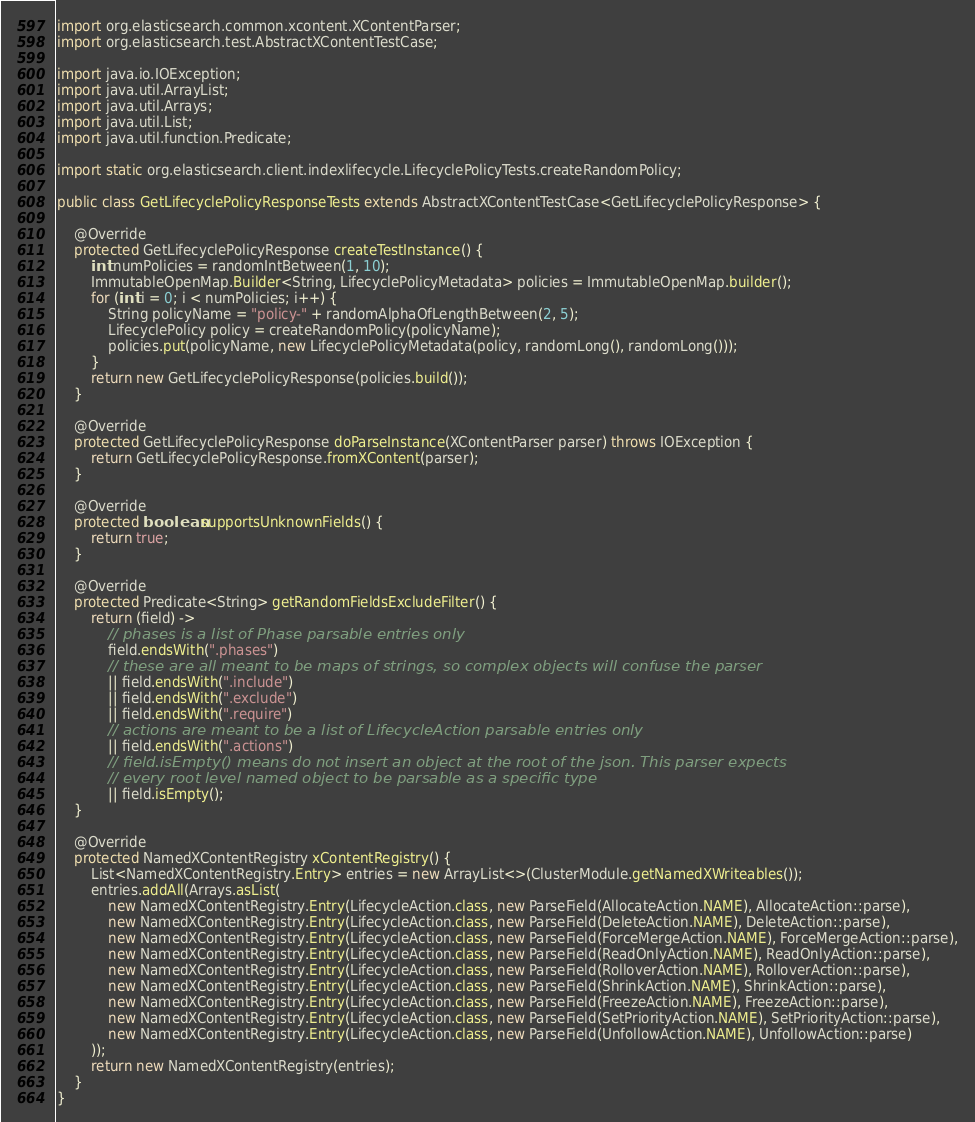<code> <loc_0><loc_0><loc_500><loc_500><_Java_>import org.elasticsearch.common.xcontent.XContentParser;
import org.elasticsearch.test.AbstractXContentTestCase;

import java.io.IOException;
import java.util.ArrayList;
import java.util.Arrays;
import java.util.List;
import java.util.function.Predicate;

import static org.elasticsearch.client.indexlifecycle.LifecyclePolicyTests.createRandomPolicy;

public class GetLifecyclePolicyResponseTests extends AbstractXContentTestCase<GetLifecyclePolicyResponse> {

    @Override
    protected GetLifecyclePolicyResponse createTestInstance() {
        int numPolicies = randomIntBetween(1, 10);
        ImmutableOpenMap.Builder<String, LifecyclePolicyMetadata> policies = ImmutableOpenMap.builder();
        for (int i = 0; i < numPolicies; i++) {
            String policyName = "policy-" + randomAlphaOfLengthBetween(2, 5);
            LifecyclePolicy policy = createRandomPolicy(policyName);
            policies.put(policyName, new LifecyclePolicyMetadata(policy, randomLong(), randomLong()));
        }
        return new GetLifecyclePolicyResponse(policies.build());
    }

    @Override
    protected GetLifecyclePolicyResponse doParseInstance(XContentParser parser) throws IOException {
        return GetLifecyclePolicyResponse.fromXContent(parser);
    }

    @Override
    protected boolean supportsUnknownFields() {
        return true;
    }

    @Override
    protected Predicate<String> getRandomFieldsExcludeFilter() {
        return (field) ->
            // phases is a list of Phase parsable entries only
            field.endsWith(".phases")
            // these are all meant to be maps of strings, so complex objects will confuse the parser
            || field.endsWith(".include")
            || field.endsWith(".exclude")
            || field.endsWith(".require")
            // actions are meant to be a list of LifecycleAction parsable entries only
            || field.endsWith(".actions")
            // field.isEmpty() means do not insert an object at the root of the json. This parser expects
            // every root level named object to be parsable as a specific type
            || field.isEmpty();
    }

    @Override
    protected NamedXContentRegistry xContentRegistry() {
        List<NamedXContentRegistry.Entry> entries = new ArrayList<>(ClusterModule.getNamedXWriteables());
        entries.addAll(Arrays.asList(
            new NamedXContentRegistry.Entry(LifecycleAction.class, new ParseField(AllocateAction.NAME), AllocateAction::parse),
            new NamedXContentRegistry.Entry(LifecycleAction.class, new ParseField(DeleteAction.NAME), DeleteAction::parse),
            new NamedXContentRegistry.Entry(LifecycleAction.class, new ParseField(ForceMergeAction.NAME), ForceMergeAction::parse),
            new NamedXContentRegistry.Entry(LifecycleAction.class, new ParseField(ReadOnlyAction.NAME), ReadOnlyAction::parse),
            new NamedXContentRegistry.Entry(LifecycleAction.class, new ParseField(RolloverAction.NAME), RolloverAction::parse),
            new NamedXContentRegistry.Entry(LifecycleAction.class, new ParseField(ShrinkAction.NAME), ShrinkAction::parse),
            new NamedXContentRegistry.Entry(LifecycleAction.class, new ParseField(FreezeAction.NAME), FreezeAction::parse),
            new NamedXContentRegistry.Entry(LifecycleAction.class, new ParseField(SetPriorityAction.NAME), SetPriorityAction::parse),
            new NamedXContentRegistry.Entry(LifecycleAction.class, new ParseField(UnfollowAction.NAME), UnfollowAction::parse)
        ));
        return new NamedXContentRegistry(entries);
    }
}
</code> 